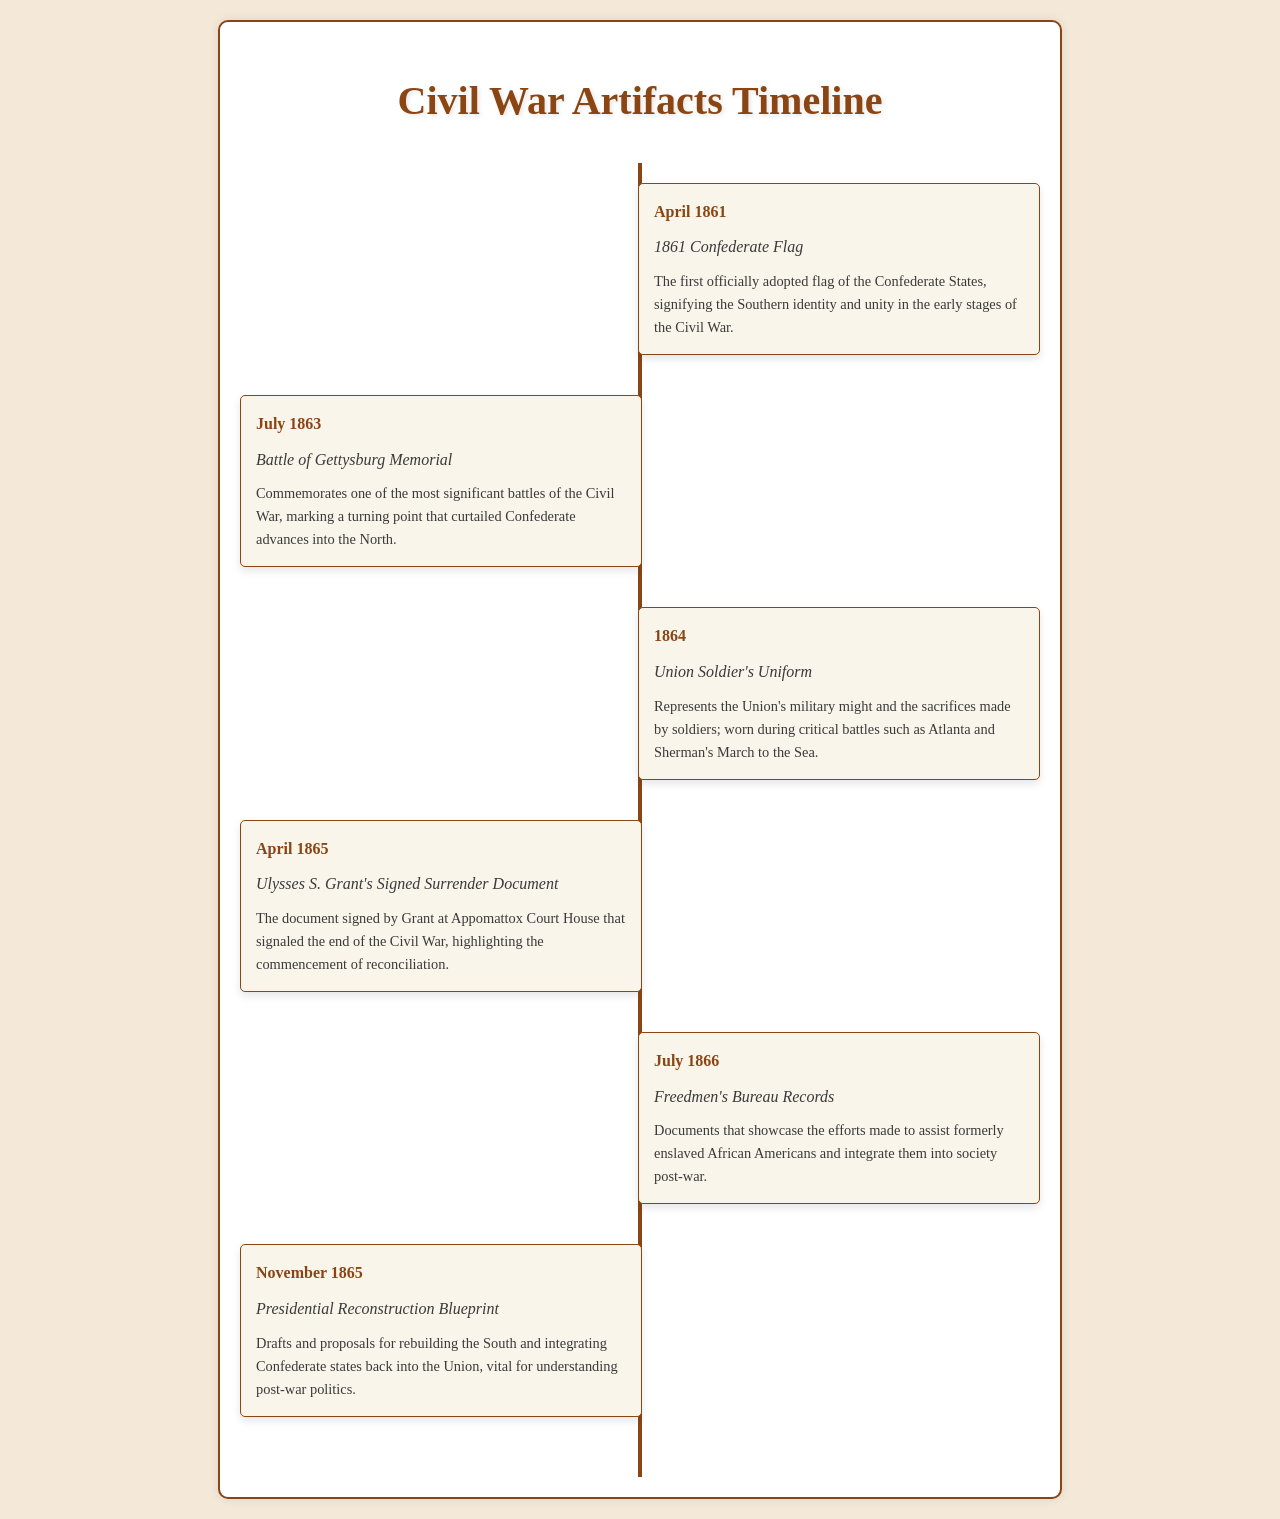What is the first artifact listed in the timeline? The first artifact mentioned in the timeline is the 1861 Confederate Flag, which marks the beginning of the timeline.
Answer: 1861 Confederate Flag When did the Battle of Gettysburg memorial appear in the timeline? The memorial for the Battle of Gettysburg is listed under the date of July 1863.
Answer: July 1863 What uniform is mentioned in 1864? The document refers to the Union Soldier's Uniform worn during critical battles in 1864.
Answer: Union Soldier's Uniform What significant event does Ulysses S. Grant's Signed Surrender Document indicate? The document indicates the end of the Civil War and the beginning of reconciliation, noted under April 1865.
Answer: end of the Civil War What records were highlighted in July 1866? The timeline features the Freedmen's Bureau Records aimed at assisting formerly enslaved African Americans.
Answer: Freedmen's Bureau Records Which artifact corresponds to November 1865? In November 1865, the Presidential Reconstruction Blueprint is the artifact of focus showing post-war rebuilding proposals.
Answer: Presidential Reconstruction Blueprint What was the significance of the 1861 Confederate Flag? The 1861 Confederate Flag signifies the Southern identity and unity in the early stages of the Civil War.
Answer: Southern identity and unity What document marked a significant turning point in July 1863? The Battle of Gettysburg Memorial marked a turning point in the Civil War noted in July 1863.
Answer: Battle of Gettysburg Memorial How did the Union Soldier's Uniform contribute to the Civil War? The uniform represents the military might of the Union and the sacrifices made by soldiers during critical battles.
Answer: military might and sacrifices 